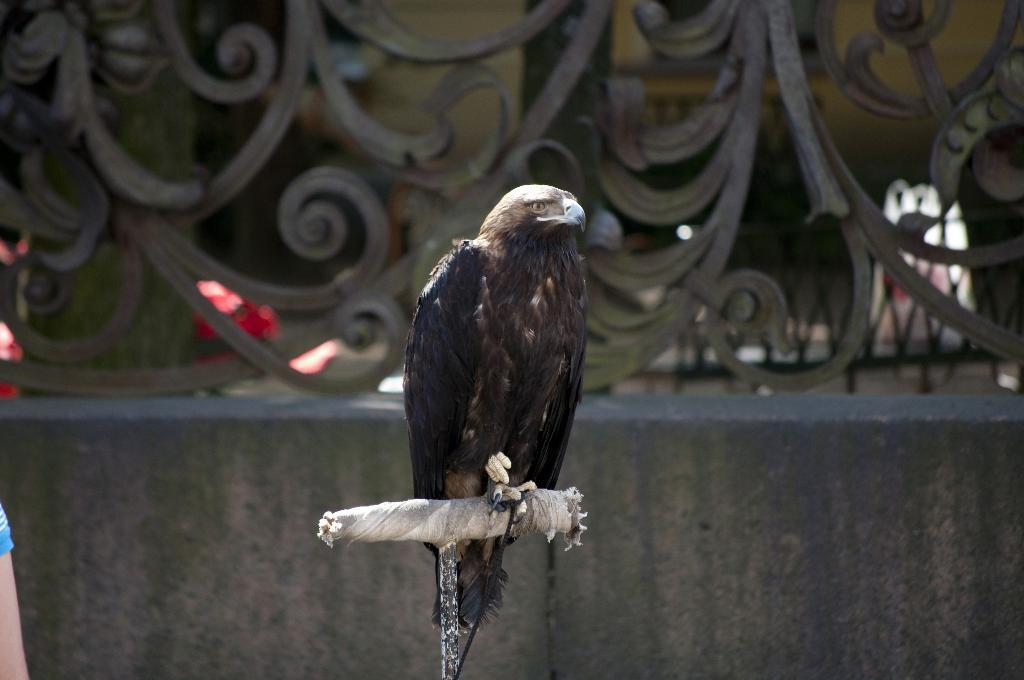What type of animal is in the image? There is a bird in the image. What color is the bird? The bird is black in color. What does the bird resemble? The bird resembles an eagle. What can be seen in the background of the image? There is a railing in the background of the image. What type of plant is the bird using to scare away its friends in the image? There is no plant or friends present in the image, and therefore no such interaction can be observed. 